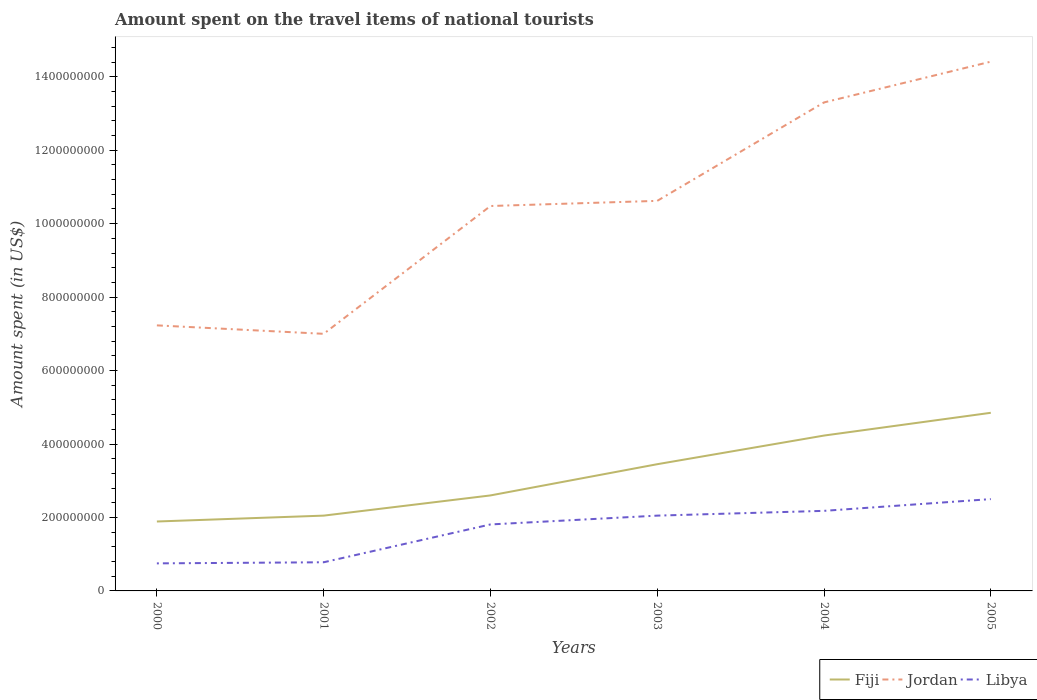How many different coloured lines are there?
Offer a very short reply. 3. Does the line corresponding to Jordan intersect with the line corresponding to Libya?
Offer a very short reply. No. Across all years, what is the maximum amount spent on the travel items of national tourists in Libya?
Offer a terse response. 7.50e+07. What is the total amount spent on the travel items of national tourists in Fiji in the graph?
Give a very brief answer. -2.18e+08. What is the difference between the highest and the second highest amount spent on the travel items of national tourists in Libya?
Give a very brief answer. 1.75e+08. What is the difference between the highest and the lowest amount spent on the travel items of national tourists in Libya?
Make the answer very short. 4. Is the amount spent on the travel items of national tourists in Jordan strictly greater than the amount spent on the travel items of national tourists in Fiji over the years?
Offer a terse response. No. How many lines are there?
Keep it short and to the point. 3. What is the difference between two consecutive major ticks on the Y-axis?
Ensure brevity in your answer.  2.00e+08. Does the graph contain grids?
Your answer should be very brief. No. How many legend labels are there?
Your response must be concise. 3. How are the legend labels stacked?
Provide a short and direct response. Horizontal. What is the title of the graph?
Give a very brief answer. Amount spent on the travel items of national tourists. Does "Sub-Saharan Africa (all income levels)" appear as one of the legend labels in the graph?
Provide a short and direct response. No. What is the label or title of the Y-axis?
Keep it short and to the point. Amount spent (in US$). What is the Amount spent (in US$) of Fiji in 2000?
Ensure brevity in your answer.  1.89e+08. What is the Amount spent (in US$) of Jordan in 2000?
Offer a terse response. 7.23e+08. What is the Amount spent (in US$) of Libya in 2000?
Your answer should be compact. 7.50e+07. What is the Amount spent (in US$) in Fiji in 2001?
Provide a short and direct response. 2.05e+08. What is the Amount spent (in US$) in Jordan in 2001?
Ensure brevity in your answer.  7.00e+08. What is the Amount spent (in US$) in Libya in 2001?
Your answer should be very brief. 7.80e+07. What is the Amount spent (in US$) in Fiji in 2002?
Keep it short and to the point. 2.60e+08. What is the Amount spent (in US$) in Jordan in 2002?
Ensure brevity in your answer.  1.05e+09. What is the Amount spent (in US$) in Libya in 2002?
Provide a short and direct response. 1.81e+08. What is the Amount spent (in US$) of Fiji in 2003?
Your answer should be very brief. 3.45e+08. What is the Amount spent (in US$) of Jordan in 2003?
Give a very brief answer. 1.06e+09. What is the Amount spent (in US$) in Libya in 2003?
Your response must be concise. 2.05e+08. What is the Amount spent (in US$) of Fiji in 2004?
Keep it short and to the point. 4.23e+08. What is the Amount spent (in US$) of Jordan in 2004?
Make the answer very short. 1.33e+09. What is the Amount spent (in US$) in Libya in 2004?
Make the answer very short. 2.18e+08. What is the Amount spent (in US$) in Fiji in 2005?
Ensure brevity in your answer.  4.85e+08. What is the Amount spent (in US$) of Jordan in 2005?
Your answer should be very brief. 1.44e+09. What is the Amount spent (in US$) of Libya in 2005?
Offer a terse response. 2.50e+08. Across all years, what is the maximum Amount spent (in US$) in Fiji?
Give a very brief answer. 4.85e+08. Across all years, what is the maximum Amount spent (in US$) of Jordan?
Your answer should be very brief. 1.44e+09. Across all years, what is the maximum Amount spent (in US$) in Libya?
Provide a succinct answer. 2.50e+08. Across all years, what is the minimum Amount spent (in US$) of Fiji?
Your answer should be very brief. 1.89e+08. Across all years, what is the minimum Amount spent (in US$) of Jordan?
Give a very brief answer. 7.00e+08. Across all years, what is the minimum Amount spent (in US$) of Libya?
Provide a succinct answer. 7.50e+07. What is the total Amount spent (in US$) of Fiji in the graph?
Your answer should be very brief. 1.91e+09. What is the total Amount spent (in US$) of Jordan in the graph?
Make the answer very short. 6.30e+09. What is the total Amount spent (in US$) in Libya in the graph?
Ensure brevity in your answer.  1.01e+09. What is the difference between the Amount spent (in US$) in Fiji in 2000 and that in 2001?
Provide a short and direct response. -1.60e+07. What is the difference between the Amount spent (in US$) in Jordan in 2000 and that in 2001?
Your response must be concise. 2.30e+07. What is the difference between the Amount spent (in US$) of Fiji in 2000 and that in 2002?
Offer a terse response. -7.10e+07. What is the difference between the Amount spent (in US$) of Jordan in 2000 and that in 2002?
Provide a short and direct response. -3.25e+08. What is the difference between the Amount spent (in US$) in Libya in 2000 and that in 2002?
Provide a succinct answer. -1.06e+08. What is the difference between the Amount spent (in US$) in Fiji in 2000 and that in 2003?
Offer a very short reply. -1.56e+08. What is the difference between the Amount spent (in US$) of Jordan in 2000 and that in 2003?
Offer a very short reply. -3.39e+08. What is the difference between the Amount spent (in US$) in Libya in 2000 and that in 2003?
Provide a short and direct response. -1.30e+08. What is the difference between the Amount spent (in US$) in Fiji in 2000 and that in 2004?
Keep it short and to the point. -2.34e+08. What is the difference between the Amount spent (in US$) in Jordan in 2000 and that in 2004?
Provide a succinct answer. -6.07e+08. What is the difference between the Amount spent (in US$) of Libya in 2000 and that in 2004?
Keep it short and to the point. -1.43e+08. What is the difference between the Amount spent (in US$) in Fiji in 2000 and that in 2005?
Make the answer very short. -2.96e+08. What is the difference between the Amount spent (in US$) of Jordan in 2000 and that in 2005?
Offer a very short reply. -7.18e+08. What is the difference between the Amount spent (in US$) in Libya in 2000 and that in 2005?
Make the answer very short. -1.75e+08. What is the difference between the Amount spent (in US$) of Fiji in 2001 and that in 2002?
Keep it short and to the point. -5.50e+07. What is the difference between the Amount spent (in US$) of Jordan in 2001 and that in 2002?
Keep it short and to the point. -3.48e+08. What is the difference between the Amount spent (in US$) in Libya in 2001 and that in 2002?
Offer a terse response. -1.03e+08. What is the difference between the Amount spent (in US$) in Fiji in 2001 and that in 2003?
Give a very brief answer. -1.40e+08. What is the difference between the Amount spent (in US$) of Jordan in 2001 and that in 2003?
Provide a short and direct response. -3.62e+08. What is the difference between the Amount spent (in US$) in Libya in 2001 and that in 2003?
Make the answer very short. -1.27e+08. What is the difference between the Amount spent (in US$) of Fiji in 2001 and that in 2004?
Make the answer very short. -2.18e+08. What is the difference between the Amount spent (in US$) in Jordan in 2001 and that in 2004?
Your answer should be very brief. -6.30e+08. What is the difference between the Amount spent (in US$) of Libya in 2001 and that in 2004?
Your answer should be compact. -1.40e+08. What is the difference between the Amount spent (in US$) in Fiji in 2001 and that in 2005?
Make the answer very short. -2.80e+08. What is the difference between the Amount spent (in US$) in Jordan in 2001 and that in 2005?
Give a very brief answer. -7.41e+08. What is the difference between the Amount spent (in US$) in Libya in 2001 and that in 2005?
Give a very brief answer. -1.72e+08. What is the difference between the Amount spent (in US$) in Fiji in 2002 and that in 2003?
Keep it short and to the point. -8.50e+07. What is the difference between the Amount spent (in US$) in Jordan in 2002 and that in 2003?
Offer a very short reply. -1.40e+07. What is the difference between the Amount spent (in US$) of Libya in 2002 and that in 2003?
Your answer should be very brief. -2.40e+07. What is the difference between the Amount spent (in US$) of Fiji in 2002 and that in 2004?
Your answer should be compact. -1.63e+08. What is the difference between the Amount spent (in US$) of Jordan in 2002 and that in 2004?
Your answer should be very brief. -2.82e+08. What is the difference between the Amount spent (in US$) in Libya in 2002 and that in 2004?
Your answer should be compact. -3.70e+07. What is the difference between the Amount spent (in US$) in Fiji in 2002 and that in 2005?
Keep it short and to the point. -2.25e+08. What is the difference between the Amount spent (in US$) in Jordan in 2002 and that in 2005?
Ensure brevity in your answer.  -3.93e+08. What is the difference between the Amount spent (in US$) of Libya in 2002 and that in 2005?
Offer a very short reply. -6.90e+07. What is the difference between the Amount spent (in US$) in Fiji in 2003 and that in 2004?
Provide a succinct answer. -7.80e+07. What is the difference between the Amount spent (in US$) of Jordan in 2003 and that in 2004?
Your answer should be compact. -2.68e+08. What is the difference between the Amount spent (in US$) of Libya in 2003 and that in 2004?
Your answer should be very brief. -1.30e+07. What is the difference between the Amount spent (in US$) of Fiji in 2003 and that in 2005?
Your answer should be very brief. -1.40e+08. What is the difference between the Amount spent (in US$) of Jordan in 2003 and that in 2005?
Your answer should be very brief. -3.79e+08. What is the difference between the Amount spent (in US$) in Libya in 2003 and that in 2005?
Your answer should be very brief. -4.50e+07. What is the difference between the Amount spent (in US$) of Fiji in 2004 and that in 2005?
Your answer should be very brief. -6.20e+07. What is the difference between the Amount spent (in US$) in Jordan in 2004 and that in 2005?
Offer a very short reply. -1.11e+08. What is the difference between the Amount spent (in US$) in Libya in 2004 and that in 2005?
Provide a short and direct response. -3.20e+07. What is the difference between the Amount spent (in US$) in Fiji in 2000 and the Amount spent (in US$) in Jordan in 2001?
Provide a short and direct response. -5.11e+08. What is the difference between the Amount spent (in US$) of Fiji in 2000 and the Amount spent (in US$) of Libya in 2001?
Offer a very short reply. 1.11e+08. What is the difference between the Amount spent (in US$) of Jordan in 2000 and the Amount spent (in US$) of Libya in 2001?
Ensure brevity in your answer.  6.45e+08. What is the difference between the Amount spent (in US$) in Fiji in 2000 and the Amount spent (in US$) in Jordan in 2002?
Your answer should be compact. -8.59e+08. What is the difference between the Amount spent (in US$) in Jordan in 2000 and the Amount spent (in US$) in Libya in 2002?
Keep it short and to the point. 5.42e+08. What is the difference between the Amount spent (in US$) of Fiji in 2000 and the Amount spent (in US$) of Jordan in 2003?
Your response must be concise. -8.73e+08. What is the difference between the Amount spent (in US$) in Fiji in 2000 and the Amount spent (in US$) in Libya in 2003?
Your response must be concise. -1.60e+07. What is the difference between the Amount spent (in US$) of Jordan in 2000 and the Amount spent (in US$) of Libya in 2003?
Provide a short and direct response. 5.18e+08. What is the difference between the Amount spent (in US$) of Fiji in 2000 and the Amount spent (in US$) of Jordan in 2004?
Ensure brevity in your answer.  -1.14e+09. What is the difference between the Amount spent (in US$) of Fiji in 2000 and the Amount spent (in US$) of Libya in 2004?
Your answer should be compact. -2.90e+07. What is the difference between the Amount spent (in US$) of Jordan in 2000 and the Amount spent (in US$) of Libya in 2004?
Give a very brief answer. 5.05e+08. What is the difference between the Amount spent (in US$) in Fiji in 2000 and the Amount spent (in US$) in Jordan in 2005?
Keep it short and to the point. -1.25e+09. What is the difference between the Amount spent (in US$) in Fiji in 2000 and the Amount spent (in US$) in Libya in 2005?
Give a very brief answer. -6.10e+07. What is the difference between the Amount spent (in US$) in Jordan in 2000 and the Amount spent (in US$) in Libya in 2005?
Keep it short and to the point. 4.73e+08. What is the difference between the Amount spent (in US$) in Fiji in 2001 and the Amount spent (in US$) in Jordan in 2002?
Your answer should be compact. -8.43e+08. What is the difference between the Amount spent (in US$) in Fiji in 2001 and the Amount spent (in US$) in Libya in 2002?
Your answer should be very brief. 2.40e+07. What is the difference between the Amount spent (in US$) in Jordan in 2001 and the Amount spent (in US$) in Libya in 2002?
Your answer should be very brief. 5.19e+08. What is the difference between the Amount spent (in US$) of Fiji in 2001 and the Amount spent (in US$) of Jordan in 2003?
Make the answer very short. -8.57e+08. What is the difference between the Amount spent (in US$) in Jordan in 2001 and the Amount spent (in US$) in Libya in 2003?
Your response must be concise. 4.95e+08. What is the difference between the Amount spent (in US$) in Fiji in 2001 and the Amount spent (in US$) in Jordan in 2004?
Provide a succinct answer. -1.12e+09. What is the difference between the Amount spent (in US$) in Fiji in 2001 and the Amount spent (in US$) in Libya in 2004?
Ensure brevity in your answer.  -1.30e+07. What is the difference between the Amount spent (in US$) in Jordan in 2001 and the Amount spent (in US$) in Libya in 2004?
Your answer should be very brief. 4.82e+08. What is the difference between the Amount spent (in US$) of Fiji in 2001 and the Amount spent (in US$) of Jordan in 2005?
Provide a succinct answer. -1.24e+09. What is the difference between the Amount spent (in US$) in Fiji in 2001 and the Amount spent (in US$) in Libya in 2005?
Provide a succinct answer. -4.50e+07. What is the difference between the Amount spent (in US$) in Jordan in 2001 and the Amount spent (in US$) in Libya in 2005?
Your response must be concise. 4.50e+08. What is the difference between the Amount spent (in US$) in Fiji in 2002 and the Amount spent (in US$) in Jordan in 2003?
Your response must be concise. -8.02e+08. What is the difference between the Amount spent (in US$) of Fiji in 2002 and the Amount spent (in US$) of Libya in 2003?
Give a very brief answer. 5.50e+07. What is the difference between the Amount spent (in US$) of Jordan in 2002 and the Amount spent (in US$) of Libya in 2003?
Offer a terse response. 8.43e+08. What is the difference between the Amount spent (in US$) of Fiji in 2002 and the Amount spent (in US$) of Jordan in 2004?
Offer a very short reply. -1.07e+09. What is the difference between the Amount spent (in US$) of Fiji in 2002 and the Amount spent (in US$) of Libya in 2004?
Your answer should be compact. 4.20e+07. What is the difference between the Amount spent (in US$) of Jordan in 2002 and the Amount spent (in US$) of Libya in 2004?
Offer a very short reply. 8.30e+08. What is the difference between the Amount spent (in US$) of Fiji in 2002 and the Amount spent (in US$) of Jordan in 2005?
Your answer should be compact. -1.18e+09. What is the difference between the Amount spent (in US$) in Fiji in 2002 and the Amount spent (in US$) in Libya in 2005?
Your answer should be compact. 1.00e+07. What is the difference between the Amount spent (in US$) of Jordan in 2002 and the Amount spent (in US$) of Libya in 2005?
Provide a succinct answer. 7.98e+08. What is the difference between the Amount spent (in US$) of Fiji in 2003 and the Amount spent (in US$) of Jordan in 2004?
Provide a short and direct response. -9.85e+08. What is the difference between the Amount spent (in US$) in Fiji in 2003 and the Amount spent (in US$) in Libya in 2004?
Offer a very short reply. 1.27e+08. What is the difference between the Amount spent (in US$) of Jordan in 2003 and the Amount spent (in US$) of Libya in 2004?
Provide a succinct answer. 8.44e+08. What is the difference between the Amount spent (in US$) in Fiji in 2003 and the Amount spent (in US$) in Jordan in 2005?
Make the answer very short. -1.10e+09. What is the difference between the Amount spent (in US$) of Fiji in 2003 and the Amount spent (in US$) of Libya in 2005?
Offer a terse response. 9.50e+07. What is the difference between the Amount spent (in US$) of Jordan in 2003 and the Amount spent (in US$) of Libya in 2005?
Keep it short and to the point. 8.12e+08. What is the difference between the Amount spent (in US$) of Fiji in 2004 and the Amount spent (in US$) of Jordan in 2005?
Provide a short and direct response. -1.02e+09. What is the difference between the Amount spent (in US$) in Fiji in 2004 and the Amount spent (in US$) in Libya in 2005?
Provide a succinct answer. 1.73e+08. What is the difference between the Amount spent (in US$) in Jordan in 2004 and the Amount spent (in US$) in Libya in 2005?
Provide a short and direct response. 1.08e+09. What is the average Amount spent (in US$) of Fiji per year?
Your answer should be compact. 3.18e+08. What is the average Amount spent (in US$) of Jordan per year?
Give a very brief answer. 1.05e+09. What is the average Amount spent (in US$) of Libya per year?
Offer a very short reply. 1.68e+08. In the year 2000, what is the difference between the Amount spent (in US$) of Fiji and Amount spent (in US$) of Jordan?
Your answer should be very brief. -5.34e+08. In the year 2000, what is the difference between the Amount spent (in US$) of Fiji and Amount spent (in US$) of Libya?
Give a very brief answer. 1.14e+08. In the year 2000, what is the difference between the Amount spent (in US$) in Jordan and Amount spent (in US$) in Libya?
Provide a succinct answer. 6.48e+08. In the year 2001, what is the difference between the Amount spent (in US$) of Fiji and Amount spent (in US$) of Jordan?
Offer a very short reply. -4.95e+08. In the year 2001, what is the difference between the Amount spent (in US$) in Fiji and Amount spent (in US$) in Libya?
Give a very brief answer. 1.27e+08. In the year 2001, what is the difference between the Amount spent (in US$) of Jordan and Amount spent (in US$) of Libya?
Make the answer very short. 6.22e+08. In the year 2002, what is the difference between the Amount spent (in US$) in Fiji and Amount spent (in US$) in Jordan?
Your response must be concise. -7.88e+08. In the year 2002, what is the difference between the Amount spent (in US$) in Fiji and Amount spent (in US$) in Libya?
Your answer should be compact. 7.90e+07. In the year 2002, what is the difference between the Amount spent (in US$) in Jordan and Amount spent (in US$) in Libya?
Offer a terse response. 8.67e+08. In the year 2003, what is the difference between the Amount spent (in US$) of Fiji and Amount spent (in US$) of Jordan?
Your answer should be very brief. -7.17e+08. In the year 2003, what is the difference between the Amount spent (in US$) in Fiji and Amount spent (in US$) in Libya?
Your answer should be compact. 1.40e+08. In the year 2003, what is the difference between the Amount spent (in US$) in Jordan and Amount spent (in US$) in Libya?
Offer a very short reply. 8.57e+08. In the year 2004, what is the difference between the Amount spent (in US$) of Fiji and Amount spent (in US$) of Jordan?
Make the answer very short. -9.07e+08. In the year 2004, what is the difference between the Amount spent (in US$) in Fiji and Amount spent (in US$) in Libya?
Provide a short and direct response. 2.05e+08. In the year 2004, what is the difference between the Amount spent (in US$) in Jordan and Amount spent (in US$) in Libya?
Keep it short and to the point. 1.11e+09. In the year 2005, what is the difference between the Amount spent (in US$) in Fiji and Amount spent (in US$) in Jordan?
Ensure brevity in your answer.  -9.56e+08. In the year 2005, what is the difference between the Amount spent (in US$) of Fiji and Amount spent (in US$) of Libya?
Provide a succinct answer. 2.35e+08. In the year 2005, what is the difference between the Amount spent (in US$) of Jordan and Amount spent (in US$) of Libya?
Give a very brief answer. 1.19e+09. What is the ratio of the Amount spent (in US$) of Fiji in 2000 to that in 2001?
Make the answer very short. 0.92. What is the ratio of the Amount spent (in US$) in Jordan in 2000 to that in 2001?
Provide a short and direct response. 1.03. What is the ratio of the Amount spent (in US$) in Libya in 2000 to that in 2001?
Ensure brevity in your answer.  0.96. What is the ratio of the Amount spent (in US$) of Fiji in 2000 to that in 2002?
Ensure brevity in your answer.  0.73. What is the ratio of the Amount spent (in US$) of Jordan in 2000 to that in 2002?
Your answer should be very brief. 0.69. What is the ratio of the Amount spent (in US$) in Libya in 2000 to that in 2002?
Make the answer very short. 0.41. What is the ratio of the Amount spent (in US$) of Fiji in 2000 to that in 2003?
Your response must be concise. 0.55. What is the ratio of the Amount spent (in US$) in Jordan in 2000 to that in 2003?
Give a very brief answer. 0.68. What is the ratio of the Amount spent (in US$) of Libya in 2000 to that in 2003?
Provide a succinct answer. 0.37. What is the ratio of the Amount spent (in US$) in Fiji in 2000 to that in 2004?
Make the answer very short. 0.45. What is the ratio of the Amount spent (in US$) of Jordan in 2000 to that in 2004?
Keep it short and to the point. 0.54. What is the ratio of the Amount spent (in US$) of Libya in 2000 to that in 2004?
Your answer should be very brief. 0.34. What is the ratio of the Amount spent (in US$) of Fiji in 2000 to that in 2005?
Your response must be concise. 0.39. What is the ratio of the Amount spent (in US$) in Jordan in 2000 to that in 2005?
Your answer should be very brief. 0.5. What is the ratio of the Amount spent (in US$) in Fiji in 2001 to that in 2002?
Provide a succinct answer. 0.79. What is the ratio of the Amount spent (in US$) in Jordan in 2001 to that in 2002?
Your response must be concise. 0.67. What is the ratio of the Amount spent (in US$) in Libya in 2001 to that in 2002?
Your response must be concise. 0.43. What is the ratio of the Amount spent (in US$) of Fiji in 2001 to that in 2003?
Offer a very short reply. 0.59. What is the ratio of the Amount spent (in US$) in Jordan in 2001 to that in 2003?
Ensure brevity in your answer.  0.66. What is the ratio of the Amount spent (in US$) in Libya in 2001 to that in 2003?
Give a very brief answer. 0.38. What is the ratio of the Amount spent (in US$) in Fiji in 2001 to that in 2004?
Your answer should be compact. 0.48. What is the ratio of the Amount spent (in US$) of Jordan in 2001 to that in 2004?
Your answer should be compact. 0.53. What is the ratio of the Amount spent (in US$) of Libya in 2001 to that in 2004?
Your answer should be compact. 0.36. What is the ratio of the Amount spent (in US$) of Fiji in 2001 to that in 2005?
Make the answer very short. 0.42. What is the ratio of the Amount spent (in US$) in Jordan in 2001 to that in 2005?
Provide a short and direct response. 0.49. What is the ratio of the Amount spent (in US$) of Libya in 2001 to that in 2005?
Provide a succinct answer. 0.31. What is the ratio of the Amount spent (in US$) of Fiji in 2002 to that in 2003?
Your response must be concise. 0.75. What is the ratio of the Amount spent (in US$) in Jordan in 2002 to that in 2003?
Ensure brevity in your answer.  0.99. What is the ratio of the Amount spent (in US$) of Libya in 2002 to that in 2003?
Offer a very short reply. 0.88. What is the ratio of the Amount spent (in US$) of Fiji in 2002 to that in 2004?
Provide a short and direct response. 0.61. What is the ratio of the Amount spent (in US$) of Jordan in 2002 to that in 2004?
Offer a very short reply. 0.79. What is the ratio of the Amount spent (in US$) in Libya in 2002 to that in 2004?
Keep it short and to the point. 0.83. What is the ratio of the Amount spent (in US$) in Fiji in 2002 to that in 2005?
Your answer should be very brief. 0.54. What is the ratio of the Amount spent (in US$) in Jordan in 2002 to that in 2005?
Offer a very short reply. 0.73. What is the ratio of the Amount spent (in US$) in Libya in 2002 to that in 2005?
Give a very brief answer. 0.72. What is the ratio of the Amount spent (in US$) of Fiji in 2003 to that in 2004?
Offer a very short reply. 0.82. What is the ratio of the Amount spent (in US$) of Jordan in 2003 to that in 2004?
Make the answer very short. 0.8. What is the ratio of the Amount spent (in US$) of Libya in 2003 to that in 2004?
Your answer should be compact. 0.94. What is the ratio of the Amount spent (in US$) in Fiji in 2003 to that in 2005?
Your response must be concise. 0.71. What is the ratio of the Amount spent (in US$) of Jordan in 2003 to that in 2005?
Offer a terse response. 0.74. What is the ratio of the Amount spent (in US$) in Libya in 2003 to that in 2005?
Provide a short and direct response. 0.82. What is the ratio of the Amount spent (in US$) in Fiji in 2004 to that in 2005?
Offer a terse response. 0.87. What is the ratio of the Amount spent (in US$) in Jordan in 2004 to that in 2005?
Make the answer very short. 0.92. What is the ratio of the Amount spent (in US$) of Libya in 2004 to that in 2005?
Give a very brief answer. 0.87. What is the difference between the highest and the second highest Amount spent (in US$) in Fiji?
Your answer should be compact. 6.20e+07. What is the difference between the highest and the second highest Amount spent (in US$) in Jordan?
Make the answer very short. 1.11e+08. What is the difference between the highest and the second highest Amount spent (in US$) of Libya?
Offer a terse response. 3.20e+07. What is the difference between the highest and the lowest Amount spent (in US$) in Fiji?
Your answer should be very brief. 2.96e+08. What is the difference between the highest and the lowest Amount spent (in US$) of Jordan?
Provide a short and direct response. 7.41e+08. What is the difference between the highest and the lowest Amount spent (in US$) of Libya?
Ensure brevity in your answer.  1.75e+08. 